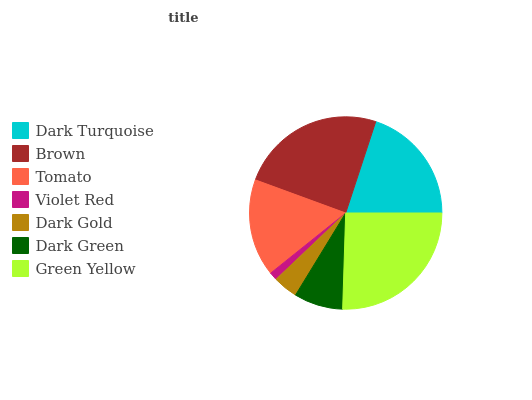Is Violet Red the minimum?
Answer yes or no. Yes. Is Green Yellow the maximum?
Answer yes or no. Yes. Is Brown the minimum?
Answer yes or no. No. Is Brown the maximum?
Answer yes or no. No. Is Brown greater than Dark Turquoise?
Answer yes or no. Yes. Is Dark Turquoise less than Brown?
Answer yes or no. Yes. Is Dark Turquoise greater than Brown?
Answer yes or no. No. Is Brown less than Dark Turquoise?
Answer yes or no. No. Is Tomato the high median?
Answer yes or no. Yes. Is Tomato the low median?
Answer yes or no. Yes. Is Dark Turquoise the high median?
Answer yes or no. No. Is Green Yellow the low median?
Answer yes or no. No. 